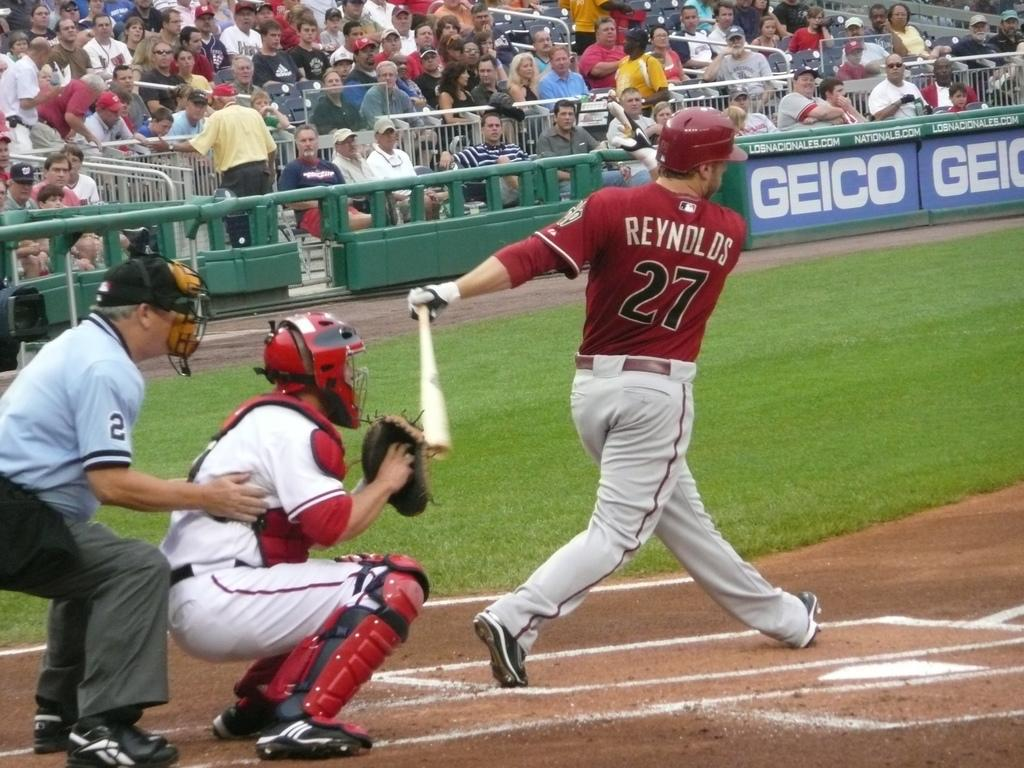<image>
Create a compact narrative representing the image presented. a player with the number 27 on their back 